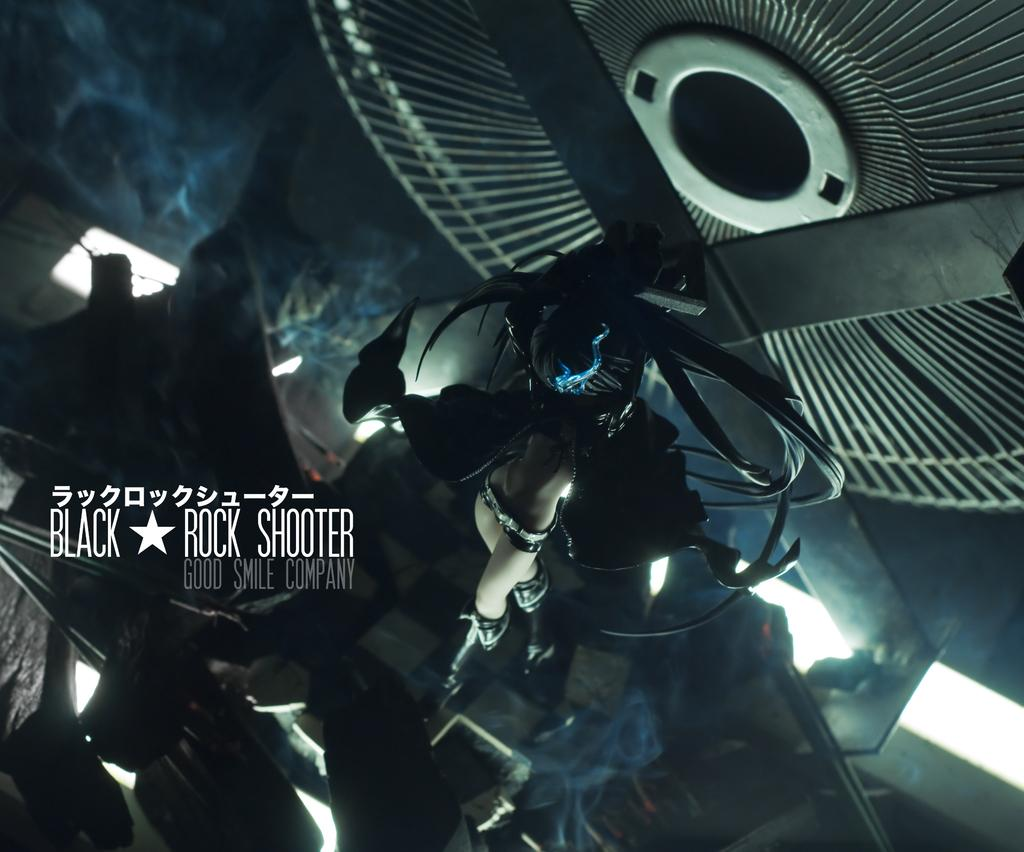Provide a one-sentence caption for the provided image. a very dark image with a woman who appears to be flying labeled Black Rock Shooter. 